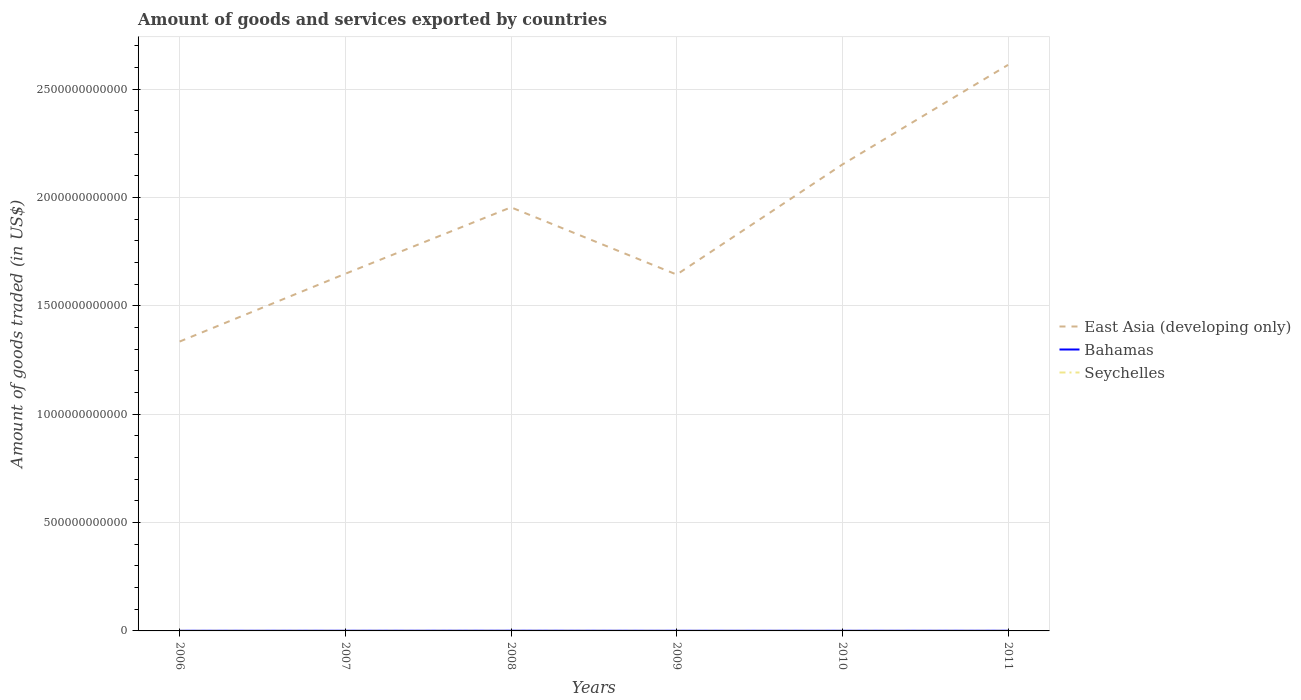Across all years, what is the maximum total amount of goods and services exported in East Asia (developing only)?
Give a very brief answer. 1.34e+12. What is the total total amount of goods and services exported in East Asia (developing only) in the graph?
Provide a succinct answer. -6.57e+11. What is the difference between the highest and the second highest total amount of goods and services exported in East Asia (developing only)?
Ensure brevity in your answer.  1.28e+12. Is the total amount of goods and services exported in East Asia (developing only) strictly greater than the total amount of goods and services exported in Bahamas over the years?
Offer a terse response. No. How many years are there in the graph?
Your answer should be very brief. 6. What is the difference between two consecutive major ticks on the Y-axis?
Make the answer very short. 5.00e+11. Does the graph contain any zero values?
Ensure brevity in your answer.  No. How many legend labels are there?
Provide a succinct answer. 3. How are the legend labels stacked?
Your answer should be compact. Vertical. What is the title of the graph?
Ensure brevity in your answer.  Amount of goods and services exported by countries. What is the label or title of the Y-axis?
Provide a short and direct response. Amount of goods traded (in US$). What is the Amount of goods traded (in US$) of East Asia (developing only) in 2006?
Your answer should be very brief. 1.34e+12. What is the Amount of goods traded (in US$) in Bahamas in 2006?
Provide a succinct answer. 7.04e+08. What is the Amount of goods traded (in US$) in Seychelles in 2006?
Your answer should be compact. 4.19e+08. What is the Amount of goods traded (in US$) of East Asia (developing only) in 2007?
Provide a succinct answer. 1.65e+12. What is the Amount of goods traded (in US$) of Bahamas in 2007?
Give a very brief answer. 8.02e+08. What is the Amount of goods traded (in US$) of Seychelles in 2007?
Make the answer very short. 3.98e+08. What is the Amount of goods traded (in US$) in East Asia (developing only) in 2008?
Offer a very short reply. 1.95e+12. What is the Amount of goods traded (in US$) of Bahamas in 2008?
Your answer should be compact. 9.56e+08. What is the Amount of goods traded (in US$) of Seychelles in 2008?
Offer a very short reply. 4.38e+08. What is the Amount of goods traded (in US$) in East Asia (developing only) in 2009?
Make the answer very short. 1.64e+12. What is the Amount of goods traded (in US$) in Bahamas in 2009?
Your answer should be very brief. 7.11e+08. What is the Amount of goods traded (in US$) of Seychelles in 2009?
Your answer should be very brief. 4.32e+08. What is the Amount of goods traded (in US$) in East Asia (developing only) in 2010?
Your response must be concise. 2.15e+12. What is the Amount of goods traded (in US$) in Bahamas in 2010?
Ensure brevity in your answer.  7.02e+08. What is the Amount of goods traded (in US$) in Seychelles in 2010?
Make the answer very short. 4.00e+08. What is the Amount of goods traded (in US$) of East Asia (developing only) in 2011?
Your response must be concise. 2.61e+12. What is the Amount of goods traded (in US$) of Bahamas in 2011?
Your answer should be very brief. 8.34e+08. What is the Amount of goods traded (in US$) of Seychelles in 2011?
Keep it short and to the point. 4.77e+08. Across all years, what is the maximum Amount of goods traded (in US$) of East Asia (developing only)?
Your answer should be compact. 2.61e+12. Across all years, what is the maximum Amount of goods traded (in US$) in Bahamas?
Make the answer very short. 9.56e+08. Across all years, what is the maximum Amount of goods traded (in US$) in Seychelles?
Offer a terse response. 4.77e+08. Across all years, what is the minimum Amount of goods traded (in US$) of East Asia (developing only)?
Your answer should be compact. 1.34e+12. Across all years, what is the minimum Amount of goods traded (in US$) in Bahamas?
Make the answer very short. 7.02e+08. Across all years, what is the minimum Amount of goods traded (in US$) in Seychelles?
Offer a very short reply. 3.98e+08. What is the total Amount of goods traded (in US$) in East Asia (developing only) in the graph?
Your answer should be very brief. 1.13e+13. What is the total Amount of goods traded (in US$) of Bahamas in the graph?
Provide a short and direct response. 4.71e+09. What is the total Amount of goods traded (in US$) of Seychelles in the graph?
Your answer should be compact. 2.56e+09. What is the difference between the Amount of goods traded (in US$) in East Asia (developing only) in 2006 and that in 2007?
Your response must be concise. -3.13e+11. What is the difference between the Amount of goods traded (in US$) in Bahamas in 2006 and that in 2007?
Provide a short and direct response. -9.83e+07. What is the difference between the Amount of goods traded (in US$) of Seychelles in 2006 and that in 2007?
Your answer should be very brief. 2.16e+07. What is the difference between the Amount of goods traded (in US$) in East Asia (developing only) in 2006 and that in 2008?
Make the answer very short. -6.19e+11. What is the difference between the Amount of goods traded (in US$) of Bahamas in 2006 and that in 2008?
Offer a very short reply. -2.52e+08. What is the difference between the Amount of goods traded (in US$) in Seychelles in 2006 and that in 2008?
Provide a short and direct response. -1.84e+07. What is the difference between the Amount of goods traded (in US$) of East Asia (developing only) in 2006 and that in 2009?
Give a very brief answer. -3.09e+11. What is the difference between the Amount of goods traded (in US$) in Bahamas in 2006 and that in 2009?
Ensure brevity in your answer.  -7.14e+06. What is the difference between the Amount of goods traded (in US$) of Seychelles in 2006 and that in 2009?
Offer a terse response. -1.26e+07. What is the difference between the Amount of goods traded (in US$) in East Asia (developing only) in 2006 and that in 2010?
Offer a very short reply. -8.17e+11. What is the difference between the Amount of goods traded (in US$) in Bahamas in 2006 and that in 2010?
Ensure brevity in your answer.  1.10e+06. What is the difference between the Amount of goods traded (in US$) of Seychelles in 2006 and that in 2010?
Your answer should be compact. 1.90e+07. What is the difference between the Amount of goods traded (in US$) in East Asia (developing only) in 2006 and that in 2011?
Offer a terse response. -1.28e+12. What is the difference between the Amount of goods traded (in US$) of Bahamas in 2006 and that in 2011?
Offer a very short reply. -1.30e+08. What is the difference between the Amount of goods traded (in US$) of Seychelles in 2006 and that in 2011?
Make the answer very short. -5.77e+07. What is the difference between the Amount of goods traded (in US$) of East Asia (developing only) in 2007 and that in 2008?
Offer a terse response. -3.07e+11. What is the difference between the Amount of goods traded (in US$) in Bahamas in 2007 and that in 2008?
Your response must be concise. -1.54e+08. What is the difference between the Amount of goods traded (in US$) in Seychelles in 2007 and that in 2008?
Your answer should be very brief. -4.01e+07. What is the difference between the Amount of goods traded (in US$) in East Asia (developing only) in 2007 and that in 2009?
Provide a short and direct response. 3.78e+09. What is the difference between the Amount of goods traded (in US$) in Bahamas in 2007 and that in 2009?
Make the answer very short. 9.12e+07. What is the difference between the Amount of goods traded (in US$) in Seychelles in 2007 and that in 2009?
Give a very brief answer. -3.42e+07. What is the difference between the Amount of goods traded (in US$) of East Asia (developing only) in 2007 and that in 2010?
Provide a short and direct response. -5.04e+11. What is the difference between the Amount of goods traded (in US$) in Bahamas in 2007 and that in 2010?
Provide a succinct answer. 9.94e+07. What is the difference between the Amount of goods traded (in US$) in Seychelles in 2007 and that in 2010?
Your answer should be very brief. -2.68e+06. What is the difference between the Amount of goods traded (in US$) in East Asia (developing only) in 2007 and that in 2011?
Offer a very short reply. -9.64e+11. What is the difference between the Amount of goods traded (in US$) of Bahamas in 2007 and that in 2011?
Provide a short and direct response. -3.17e+07. What is the difference between the Amount of goods traded (in US$) of Seychelles in 2007 and that in 2011?
Your answer should be very brief. -7.93e+07. What is the difference between the Amount of goods traded (in US$) of East Asia (developing only) in 2008 and that in 2009?
Your answer should be very brief. 3.10e+11. What is the difference between the Amount of goods traded (in US$) of Bahamas in 2008 and that in 2009?
Offer a terse response. 2.45e+08. What is the difference between the Amount of goods traded (in US$) in Seychelles in 2008 and that in 2009?
Your answer should be very brief. 5.81e+06. What is the difference between the Amount of goods traded (in US$) of East Asia (developing only) in 2008 and that in 2010?
Offer a terse response. -1.98e+11. What is the difference between the Amount of goods traded (in US$) in Bahamas in 2008 and that in 2010?
Make the answer very short. 2.53e+08. What is the difference between the Amount of goods traded (in US$) of Seychelles in 2008 and that in 2010?
Your answer should be compact. 3.74e+07. What is the difference between the Amount of goods traded (in US$) of East Asia (developing only) in 2008 and that in 2011?
Offer a terse response. -6.57e+11. What is the difference between the Amount of goods traded (in US$) in Bahamas in 2008 and that in 2011?
Your response must be concise. 1.22e+08. What is the difference between the Amount of goods traded (in US$) in Seychelles in 2008 and that in 2011?
Your answer should be compact. -3.93e+07. What is the difference between the Amount of goods traded (in US$) of East Asia (developing only) in 2009 and that in 2010?
Offer a very short reply. -5.08e+11. What is the difference between the Amount of goods traded (in US$) in Bahamas in 2009 and that in 2010?
Offer a terse response. 8.24e+06. What is the difference between the Amount of goods traded (in US$) in Seychelles in 2009 and that in 2010?
Your response must be concise. 3.16e+07. What is the difference between the Amount of goods traded (in US$) in East Asia (developing only) in 2009 and that in 2011?
Your response must be concise. -9.68e+11. What is the difference between the Amount of goods traded (in US$) of Bahamas in 2009 and that in 2011?
Provide a short and direct response. -1.23e+08. What is the difference between the Amount of goods traded (in US$) in Seychelles in 2009 and that in 2011?
Your answer should be compact. -4.51e+07. What is the difference between the Amount of goods traded (in US$) of East Asia (developing only) in 2010 and that in 2011?
Provide a short and direct response. -4.60e+11. What is the difference between the Amount of goods traded (in US$) of Bahamas in 2010 and that in 2011?
Make the answer very short. -1.31e+08. What is the difference between the Amount of goods traded (in US$) in Seychelles in 2010 and that in 2011?
Ensure brevity in your answer.  -7.67e+07. What is the difference between the Amount of goods traded (in US$) of East Asia (developing only) in 2006 and the Amount of goods traded (in US$) of Bahamas in 2007?
Make the answer very short. 1.33e+12. What is the difference between the Amount of goods traded (in US$) in East Asia (developing only) in 2006 and the Amount of goods traded (in US$) in Seychelles in 2007?
Ensure brevity in your answer.  1.33e+12. What is the difference between the Amount of goods traded (in US$) of Bahamas in 2006 and the Amount of goods traded (in US$) of Seychelles in 2007?
Offer a very short reply. 3.06e+08. What is the difference between the Amount of goods traded (in US$) of East Asia (developing only) in 2006 and the Amount of goods traded (in US$) of Bahamas in 2008?
Your response must be concise. 1.33e+12. What is the difference between the Amount of goods traded (in US$) of East Asia (developing only) in 2006 and the Amount of goods traded (in US$) of Seychelles in 2008?
Your answer should be compact. 1.33e+12. What is the difference between the Amount of goods traded (in US$) of Bahamas in 2006 and the Amount of goods traded (in US$) of Seychelles in 2008?
Your response must be concise. 2.66e+08. What is the difference between the Amount of goods traded (in US$) of East Asia (developing only) in 2006 and the Amount of goods traded (in US$) of Bahamas in 2009?
Provide a succinct answer. 1.33e+12. What is the difference between the Amount of goods traded (in US$) of East Asia (developing only) in 2006 and the Amount of goods traded (in US$) of Seychelles in 2009?
Offer a very short reply. 1.33e+12. What is the difference between the Amount of goods traded (in US$) of Bahamas in 2006 and the Amount of goods traded (in US$) of Seychelles in 2009?
Make the answer very short. 2.72e+08. What is the difference between the Amount of goods traded (in US$) of East Asia (developing only) in 2006 and the Amount of goods traded (in US$) of Bahamas in 2010?
Keep it short and to the point. 1.33e+12. What is the difference between the Amount of goods traded (in US$) in East Asia (developing only) in 2006 and the Amount of goods traded (in US$) in Seychelles in 2010?
Provide a short and direct response. 1.33e+12. What is the difference between the Amount of goods traded (in US$) of Bahamas in 2006 and the Amount of goods traded (in US$) of Seychelles in 2010?
Offer a terse response. 3.03e+08. What is the difference between the Amount of goods traded (in US$) of East Asia (developing only) in 2006 and the Amount of goods traded (in US$) of Bahamas in 2011?
Make the answer very short. 1.33e+12. What is the difference between the Amount of goods traded (in US$) of East Asia (developing only) in 2006 and the Amount of goods traded (in US$) of Seychelles in 2011?
Offer a terse response. 1.33e+12. What is the difference between the Amount of goods traded (in US$) of Bahamas in 2006 and the Amount of goods traded (in US$) of Seychelles in 2011?
Provide a succinct answer. 2.27e+08. What is the difference between the Amount of goods traded (in US$) of East Asia (developing only) in 2007 and the Amount of goods traded (in US$) of Bahamas in 2008?
Offer a very short reply. 1.65e+12. What is the difference between the Amount of goods traded (in US$) of East Asia (developing only) in 2007 and the Amount of goods traded (in US$) of Seychelles in 2008?
Ensure brevity in your answer.  1.65e+12. What is the difference between the Amount of goods traded (in US$) of Bahamas in 2007 and the Amount of goods traded (in US$) of Seychelles in 2008?
Give a very brief answer. 3.64e+08. What is the difference between the Amount of goods traded (in US$) of East Asia (developing only) in 2007 and the Amount of goods traded (in US$) of Bahamas in 2009?
Offer a very short reply. 1.65e+12. What is the difference between the Amount of goods traded (in US$) of East Asia (developing only) in 2007 and the Amount of goods traded (in US$) of Seychelles in 2009?
Ensure brevity in your answer.  1.65e+12. What is the difference between the Amount of goods traded (in US$) in Bahamas in 2007 and the Amount of goods traded (in US$) in Seychelles in 2009?
Keep it short and to the point. 3.70e+08. What is the difference between the Amount of goods traded (in US$) of East Asia (developing only) in 2007 and the Amount of goods traded (in US$) of Bahamas in 2010?
Your response must be concise. 1.65e+12. What is the difference between the Amount of goods traded (in US$) in East Asia (developing only) in 2007 and the Amount of goods traded (in US$) in Seychelles in 2010?
Give a very brief answer. 1.65e+12. What is the difference between the Amount of goods traded (in US$) in Bahamas in 2007 and the Amount of goods traded (in US$) in Seychelles in 2010?
Your response must be concise. 4.02e+08. What is the difference between the Amount of goods traded (in US$) of East Asia (developing only) in 2007 and the Amount of goods traded (in US$) of Bahamas in 2011?
Provide a succinct answer. 1.65e+12. What is the difference between the Amount of goods traded (in US$) in East Asia (developing only) in 2007 and the Amount of goods traded (in US$) in Seychelles in 2011?
Keep it short and to the point. 1.65e+12. What is the difference between the Amount of goods traded (in US$) of Bahamas in 2007 and the Amount of goods traded (in US$) of Seychelles in 2011?
Provide a short and direct response. 3.25e+08. What is the difference between the Amount of goods traded (in US$) in East Asia (developing only) in 2008 and the Amount of goods traded (in US$) in Bahamas in 2009?
Provide a succinct answer. 1.95e+12. What is the difference between the Amount of goods traded (in US$) of East Asia (developing only) in 2008 and the Amount of goods traded (in US$) of Seychelles in 2009?
Give a very brief answer. 1.95e+12. What is the difference between the Amount of goods traded (in US$) in Bahamas in 2008 and the Amount of goods traded (in US$) in Seychelles in 2009?
Provide a short and direct response. 5.24e+08. What is the difference between the Amount of goods traded (in US$) in East Asia (developing only) in 2008 and the Amount of goods traded (in US$) in Bahamas in 2010?
Your response must be concise. 1.95e+12. What is the difference between the Amount of goods traded (in US$) of East Asia (developing only) in 2008 and the Amount of goods traded (in US$) of Seychelles in 2010?
Your answer should be compact. 1.95e+12. What is the difference between the Amount of goods traded (in US$) of Bahamas in 2008 and the Amount of goods traded (in US$) of Seychelles in 2010?
Provide a succinct answer. 5.56e+08. What is the difference between the Amount of goods traded (in US$) in East Asia (developing only) in 2008 and the Amount of goods traded (in US$) in Bahamas in 2011?
Your response must be concise. 1.95e+12. What is the difference between the Amount of goods traded (in US$) in East Asia (developing only) in 2008 and the Amount of goods traded (in US$) in Seychelles in 2011?
Make the answer very short. 1.95e+12. What is the difference between the Amount of goods traded (in US$) in Bahamas in 2008 and the Amount of goods traded (in US$) in Seychelles in 2011?
Give a very brief answer. 4.79e+08. What is the difference between the Amount of goods traded (in US$) of East Asia (developing only) in 2009 and the Amount of goods traded (in US$) of Bahamas in 2010?
Provide a succinct answer. 1.64e+12. What is the difference between the Amount of goods traded (in US$) in East Asia (developing only) in 2009 and the Amount of goods traded (in US$) in Seychelles in 2010?
Provide a succinct answer. 1.64e+12. What is the difference between the Amount of goods traded (in US$) of Bahamas in 2009 and the Amount of goods traded (in US$) of Seychelles in 2010?
Make the answer very short. 3.10e+08. What is the difference between the Amount of goods traded (in US$) in East Asia (developing only) in 2009 and the Amount of goods traded (in US$) in Bahamas in 2011?
Your response must be concise. 1.64e+12. What is the difference between the Amount of goods traded (in US$) in East Asia (developing only) in 2009 and the Amount of goods traded (in US$) in Seychelles in 2011?
Your answer should be compact. 1.64e+12. What is the difference between the Amount of goods traded (in US$) in Bahamas in 2009 and the Amount of goods traded (in US$) in Seychelles in 2011?
Offer a very short reply. 2.34e+08. What is the difference between the Amount of goods traded (in US$) in East Asia (developing only) in 2010 and the Amount of goods traded (in US$) in Bahamas in 2011?
Provide a succinct answer. 2.15e+12. What is the difference between the Amount of goods traded (in US$) of East Asia (developing only) in 2010 and the Amount of goods traded (in US$) of Seychelles in 2011?
Offer a very short reply. 2.15e+12. What is the difference between the Amount of goods traded (in US$) of Bahamas in 2010 and the Amount of goods traded (in US$) of Seychelles in 2011?
Your answer should be very brief. 2.26e+08. What is the average Amount of goods traded (in US$) in East Asia (developing only) per year?
Make the answer very short. 1.89e+12. What is the average Amount of goods traded (in US$) in Bahamas per year?
Your answer should be compact. 7.85e+08. What is the average Amount of goods traded (in US$) of Seychelles per year?
Your answer should be compact. 4.27e+08. In the year 2006, what is the difference between the Amount of goods traded (in US$) of East Asia (developing only) and Amount of goods traded (in US$) of Bahamas?
Offer a terse response. 1.33e+12. In the year 2006, what is the difference between the Amount of goods traded (in US$) in East Asia (developing only) and Amount of goods traded (in US$) in Seychelles?
Provide a succinct answer. 1.33e+12. In the year 2006, what is the difference between the Amount of goods traded (in US$) in Bahamas and Amount of goods traded (in US$) in Seychelles?
Your response must be concise. 2.84e+08. In the year 2007, what is the difference between the Amount of goods traded (in US$) of East Asia (developing only) and Amount of goods traded (in US$) of Bahamas?
Offer a very short reply. 1.65e+12. In the year 2007, what is the difference between the Amount of goods traded (in US$) of East Asia (developing only) and Amount of goods traded (in US$) of Seychelles?
Offer a very short reply. 1.65e+12. In the year 2007, what is the difference between the Amount of goods traded (in US$) in Bahamas and Amount of goods traded (in US$) in Seychelles?
Make the answer very short. 4.04e+08. In the year 2008, what is the difference between the Amount of goods traded (in US$) in East Asia (developing only) and Amount of goods traded (in US$) in Bahamas?
Offer a terse response. 1.95e+12. In the year 2008, what is the difference between the Amount of goods traded (in US$) of East Asia (developing only) and Amount of goods traded (in US$) of Seychelles?
Ensure brevity in your answer.  1.95e+12. In the year 2008, what is the difference between the Amount of goods traded (in US$) of Bahamas and Amount of goods traded (in US$) of Seychelles?
Your answer should be compact. 5.18e+08. In the year 2009, what is the difference between the Amount of goods traded (in US$) in East Asia (developing only) and Amount of goods traded (in US$) in Bahamas?
Make the answer very short. 1.64e+12. In the year 2009, what is the difference between the Amount of goods traded (in US$) in East Asia (developing only) and Amount of goods traded (in US$) in Seychelles?
Keep it short and to the point. 1.64e+12. In the year 2009, what is the difference between the Amount of goods traded (in US$) of Bahamas and Amount of goods traded (in US$) of Seychelles?
Offer a very short reply. 2.79e+08. In the year 2010, what is the difference between the Amount of goods traded (in US$) of East Asia (developing only) and Amount of goods traded (in US$) of Bahamas?
Provide a succinct answer. 2.15e+12. In the year 2010, what is the difference between the Amount of goods traded (in US$) in East Asia (developing only) and Amount of goods traded (in US$) in Seychelles?
Ensure brevity in your answer.  2.15e+12. In the year 2010, what is the difference between the Amount of goods traded (in US$) of Bahamas and Amount of goods traded (in US$) of Seychelles?
Give a very brief answer. 3.02e+08. In the year 2011, what is the difference between the Amount of goods traded (in US$) in East Asia (developing only) and Amount of goods traded (in US$) in Bahamas?
Your answer should be very brief. 2.61e+12. In the year 2011, what is the difference between the Amount of goods traded (in US$) in East Asia (developing only) and Amount of goods traded (in US$) in Seychelles?
Your answer should be compact. 2.61e+12. In the year 2011, what is the difference between the Amount of goods traded (in US$) of Bahamas and Amount of goods traded (in US$) of Seychelles?
Provide a short and direct response. 3.57e+08. What is the ratio of the Amount of goods traded (in US$) of East Asia (developing only) in 2006 to that in 2007?
Make the answer very short. 0.81. What is the ratio of the Amount of goods traded (in US$) in Bahamas in 2006 to that in 2007?
Provide a short and direct response. 0.88. What is the ratio of the Amount of goods traded (in US$) in Seychelles in 2006 to that in 2007?
Provide a short and direct response. 1.05. What is the ratio of the Amount of goods traded (in US$) of East Asia (developing only) in 2006 to that in 2008?
Your answer should be very brief. 0.68. What is the ratio of the Amount of goods traded (in US$) of Bahamas in 2006 to that in 2008?
Offer a terse response. 0.74. What is the ratio of the Amount of goods traded (in US$) of Seychelles in 2006 to that in 2008?
Make the answer very short. 0.96. What is the ratio of the Amount of goods traded (in US$) of East Asia (developing only) in 2006 to that in 2009?
Give a very brief answer. 0.81. What is the ratio of the Amount of goods traded (in US$) in Bahamas in 2006 to that in 2009?
Your response must be concise. 0.99. What is the ratio of the Amount of goods traded (in US$) in Seychelles in 2006 to that in 2009?
Make the answer very short. 0.97. What is the ratio of the Amount of goods traded (in US$) of East Asia (developing only) in 2006 to that in 2010?
Provide a succinct answer. 0.62. What is the ratio of the Amount of goods traded (in US$) of Seychelles in 2006 to that in 2010?
Make the answer very short. 1.05. What is the ratio of the Amount of goods traded (in US$) of East Asia (developing only) in 2006 to that in 2011?
Make the answer very short. 0.51. What is the ratio of the Amount of goods traded (in US$) in Bahamas in 2006 to that in 2011?
Ensure brevity in your answer.  0.84. What is the ratio of the Amount of goods traded (in US$) of Seychelles in 2006 to that in 2011?
Provide a short and direct response. 0.88. What is the ratio of the Amount of goods traded (in US$) in East Asia (developing only) in 2007 to that in 2008?
Provide a succinct answer. 0.84. What is the ratio of the Amount of goods traded (in US$) of Bahamas in 2007 to that in 2008?
Offer a very short reply. 0.84. What is the ratio of the Amount of goods traded (in US$) of Seychelles in 2007 to that in 2008?
Your answer should be very brief. 0.91. What is the ratio of the Amount of goods traded (in US$) in East Asia (developing only) in 2007 to that in 2009?
Offer a terse response. 1. What is the ratio of the Amount of goods traded (in US$) of Bahamas in 2007 to that in 2009?
Offer a terse response. 1.13. What is the ratio of the Amount of goods traded (in US$) of Seychelles in 2007 to that in 2009?
Offer a terse response. 0.92. What is the ratio of the Amount of goods traded (in US$) of East Asia (developing only) in 2007 to that in 2010?
Make the answer very short. 0.77. What is the ratio of the Amount of goods traded (in US$) in Bahamas in 2007 to that in 2010?
Ensure brevity in your answer.  1.14. What is the ratio of the Amount of goods traded (in US$) in East Asia (developing only) in 2007 to that in 2011?
Provide a short and direct response. 0.63. What is the ratio of the Amount of goods traded (in US$) in Bahamas in 2007 to that in 2011?
Provide a short and direct response. 0.96. What is the ratio of the Amount of goods traded (in US$) of Seychelles in 2007 to that in 2011?
Make the answer very short. 0.83. What is the ratio of the Amount of goods traded (in US$) in East Asia (developing only) in 2008 to that in 2009?
Provide a short and direct response. 1.19. What is the ratio of the Amount of goods traded (in US$) in Bahamas in 2008 to that in 2009?
Your response must be concise. 1.34. What is the ratio of the Amount of goods traded (in US$) in Seychelles in 2008 to that in 2009?
Give a very brief answer. 1.01. What is the ratio of the Amount of goods traded (in US$) in East Asia (developing only) in 2008 to that in 2010?
Your response must be concise. 0.91. What is the ratio of the Amount of goods traded (in US$) of Bahamas in 2008 to that in 2010?
Your answer should be very brief. 1.36. What is the ratio of the Amount of goods traded (in US$) in Seychelles in 2008 to that in 2010?
Offer a very short reply. 1.09. What is the ratio of the Amount of goods traded (in US$) in East Asia (developing only) in 2008 to that in 2011?
Offer a very short reply. 0.75. What is the ratio of the Amount of goods traded (in US$) in Bahamas in 2008 to that in 2011?
Your response must be concise. 1.15. What is the ratio of the Amount of goods traded (in US$) of Seychelles in 2008 to that in 2011?
Give a very brief answer. 0.92. What is the ratio of the Amount of goods traded (in US$) in East Asia (developing only) in 2009 to that in 2010?
Offer a terse response. 0.76. What is the ratio of the Amount of goods traded (in US$) in Bahamas in 2009 to that in 2010?
Your answer should be compact. 1.01. What is the ratio of the Amount of goods traded (in US$) of Seychelles in 2009 to that in 2010?
Provide a short and direct response. 1.08. What is the ratio of the Amount of goods traded (in US$) of East Asia (developing only) in 2009 to that in 2011?
Give a very brief answer. 0.63. What is the ratio of the Amount of goods traded (in US$) of Bahamas in 2009 to that in 2011?
Provide a short and direct response. 0.85. What is the ratio of the Amount of goods traded (in US$) of Seychelles in 2009 to that in 2011?
Ensure brevity in your answer.  0.91. What is the ratio of the Amount of goods traded (in US$) in East Asia (developing only) in 2010 to that in 2011?
Keep it short and to the point. 0.82. What is the ratio of the Amount of goods traded (in US$) of Bahamas in 2010 to that in 2011?
Provide a short and direct response. 0.84. What is the ratio of the Amount of goods traded (in US$) in Seychelles in 2010 to that in 2011?
Your answer should be very brief. 0.84. What is the difference between the highest and the second highest Amount of goods traded (in US$) of East Asia (developing only)?
Your answer should be very brief. 4.60e+11. What is the difference between the highest and the second highest Amount of goods traded (in US$) of Bahamas?
Keep it short and to the point. 1.22e+08. What is the difference between the highest and the second highest Amount of goods traded (in US$) in Seychelles?
Your answer should be compact. 3.93e+07. What is the difference between the highest and the lowest Amount of goods traded (in US$) of East Asia (developing only)?
Offer a terse response. 1.28e+12. What is the difference between the highest and the lowest Amount of goods traded (in US$) in Bahamas?
Provide a short and direct response. 2.53e+08. What is the difference between the highest and the lowest Amount of goods traded (in US$) in Seychelles?
Give a very brief answer. 7.93e+07. 